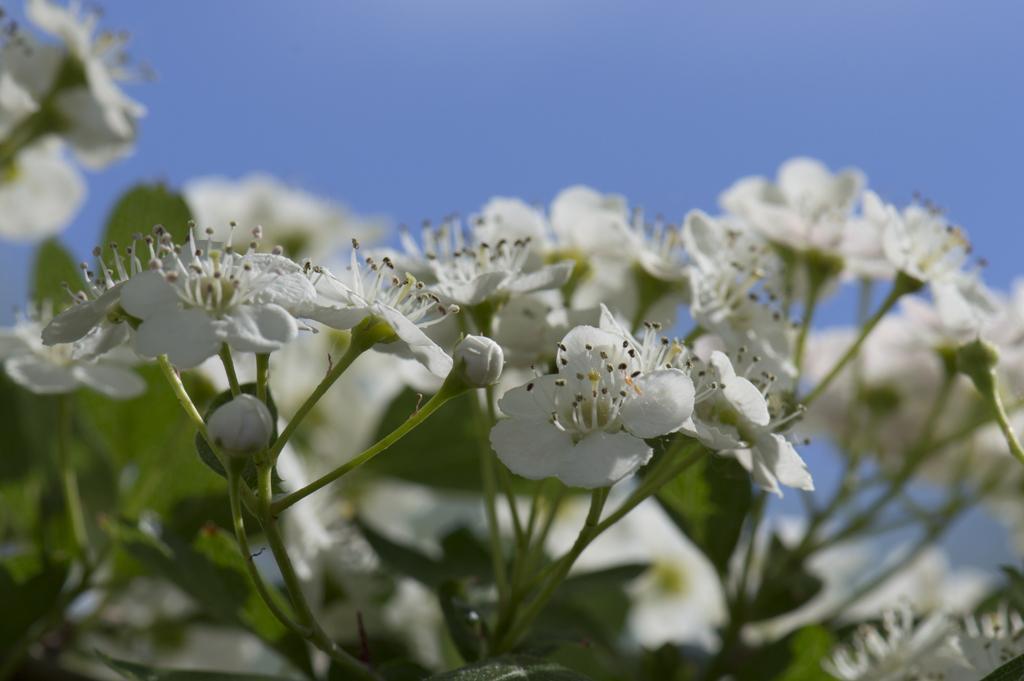Describe this image in one or two sentences. There are white color flowers in the foreground area of the image and the sky in the background. 